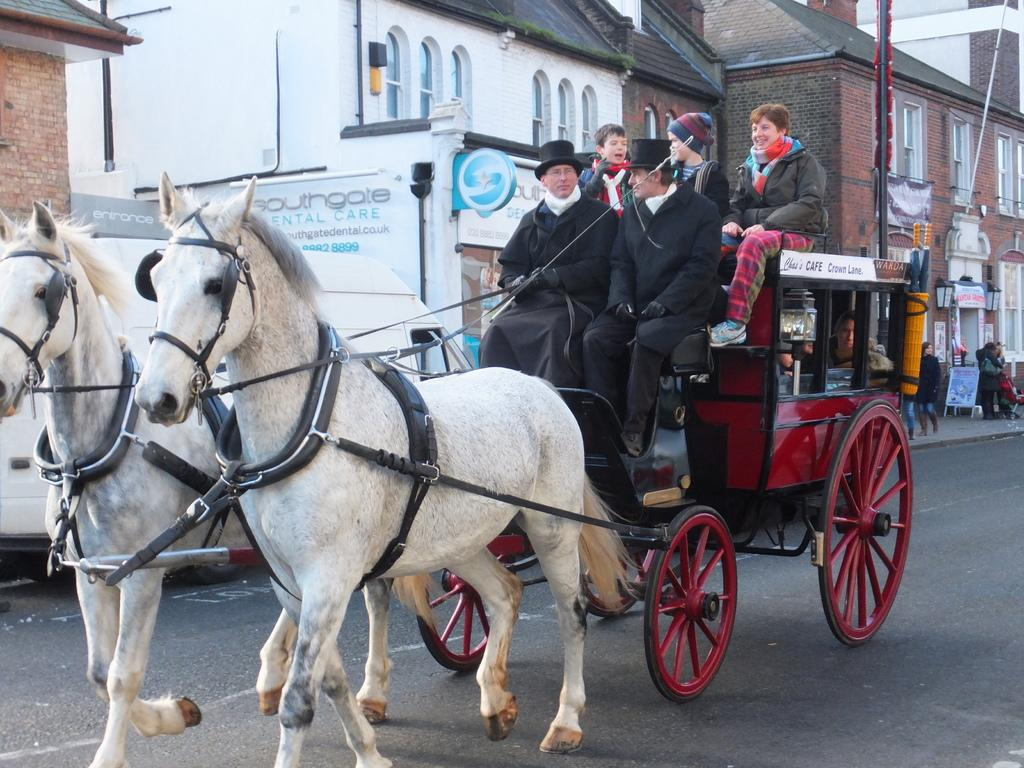What mode of transportation are the people using in the image? The people are sitting on a tonga in the image. What is pulling the tonga? The tonga is being pulled by horses. How many horses are visible in the image? There are two horses on the road in the image. What can be seen in the background of the image? There is a building and a pole in the background of the image. What type of plant is being used as a weapon in the image? There is no plant being used as a weapon in the image; it features a tonga being pulled by horses with people sitting on it. 